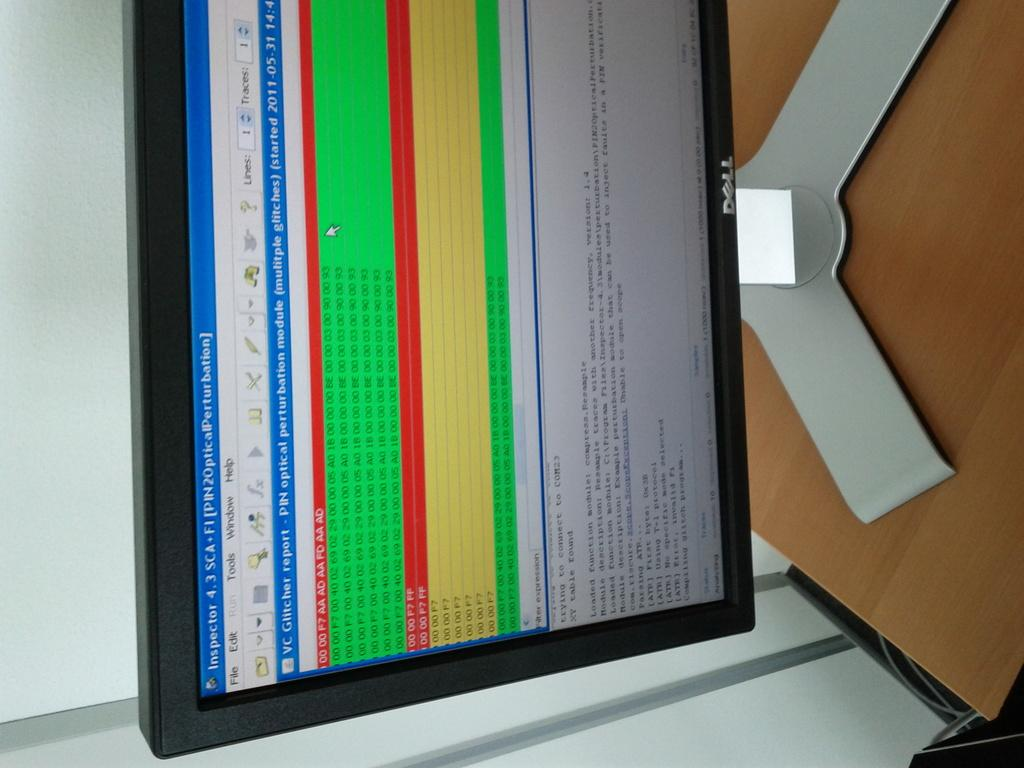What piece of furniture is located on the right side of the image? There is a table on the right side of the image. What is placed on the table in the image? A monitor is placed on the table. What is visible on the left side of the image? There is a wall on the left side of the image. What type of cracker is being used to control the monitor in the image? There is no cracker present in the image, and the monitor is not being controlled by any cracker. Are there any pests visible on the wall in the image? There is no mention of pests in the provided facts, and no pests are visible on the wall in the image. 